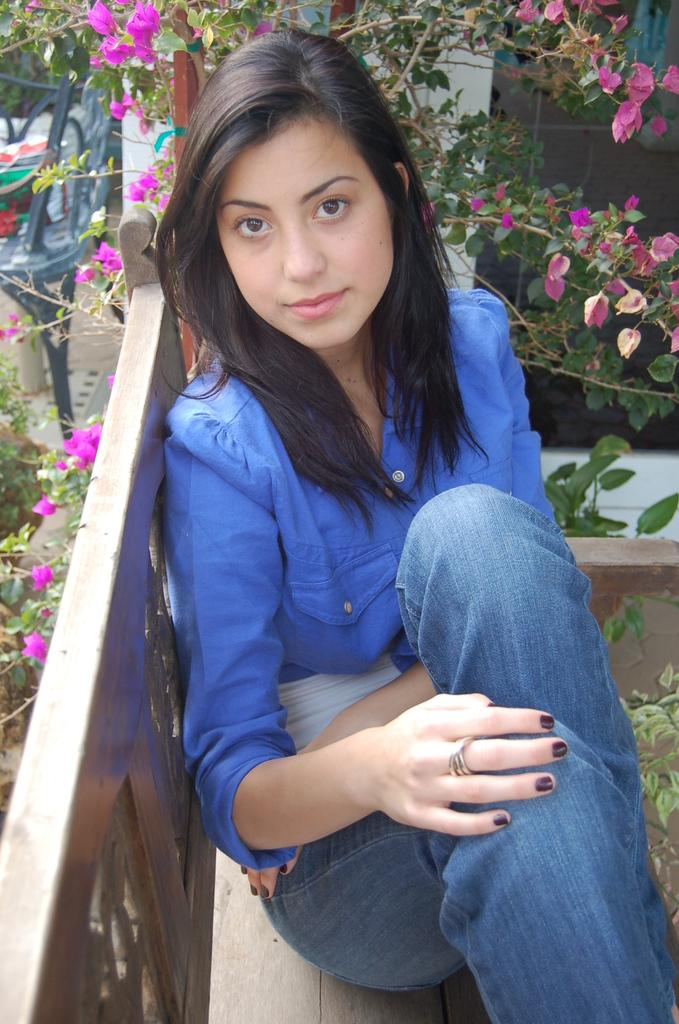Who is present in the image? There is a woman in the image. What is the woman doing in the image? The woman is sitting on a bench. What is the woman's facial expression in the image? The woman is smiling. What can be seen in the background of the image? There is a chair, plants with flowers, and some objects in the background of the image. What type of metal is used to make the stitch on the woman's clothing in the image? There is no mention of any stitch or metal in the image; the woman is simply sitting on a bench and smiling. 